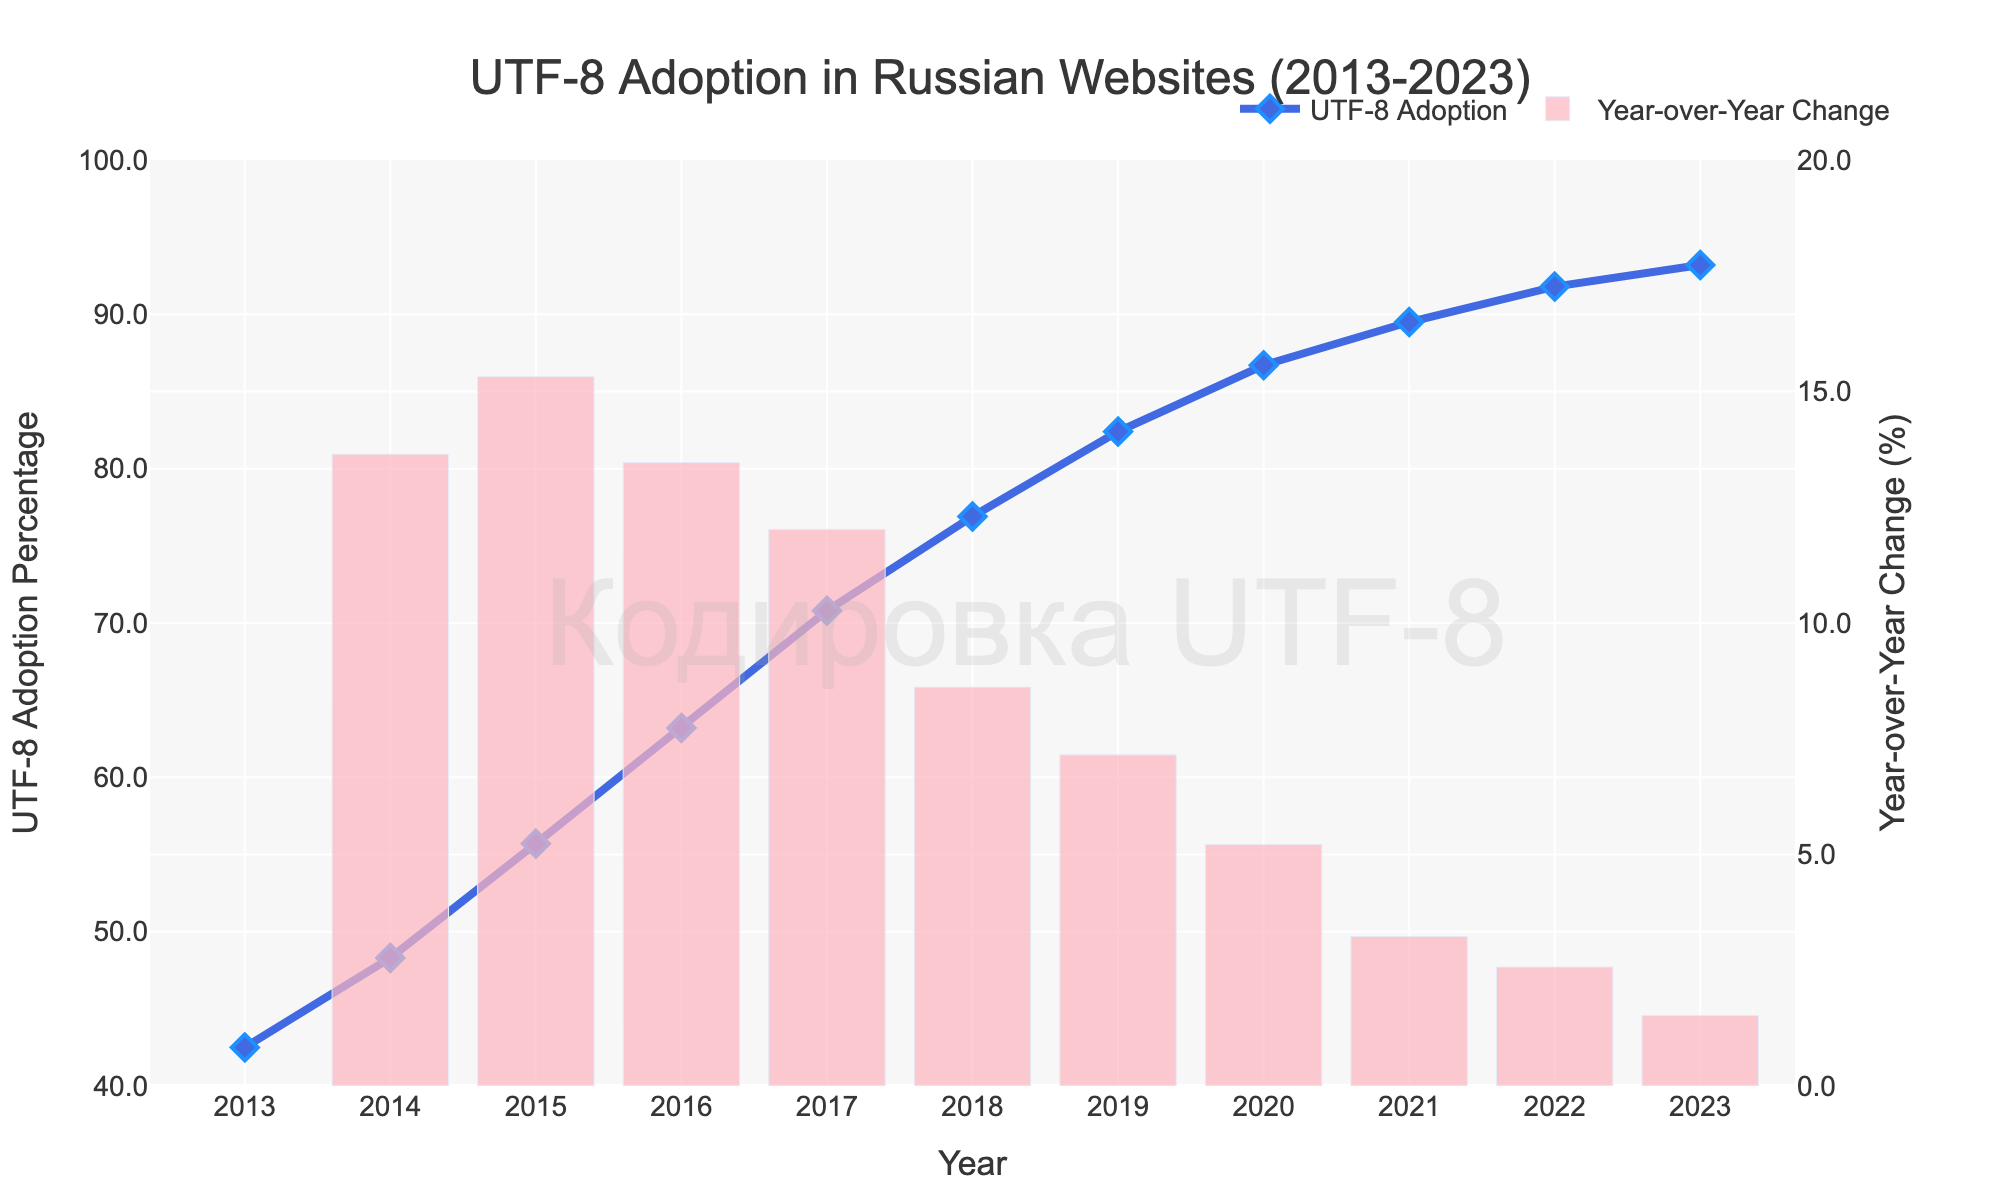What was the year with the highest increase in UTF-8 adoption? To find this, look at the bar graph showing year-over-year changes. The tallest bar represents the highest increase. In the figure, the largest year-over-year change appears to be between 2016 and 2017.
Answer: 2017 What is the overall trend of UTF-8 adoption from 2013 to 2023? Observe the line chart for the UTF-8 adoption percentage. The line shows a steady upward trend from 42.5% in 2013 to 93.2% in 2023, indicating an increasing adoption rate over the years.
Answer: Increasing Between which consecutive years was the year-over-year change the smallest? Refer to the bar graph. Identify the smallest bar, which represents the smallest year-over-year change. The shortest bar is located between 2022 and 2023.
Answer: 2022 to 2023 Compare the UTF-8 adoption rates in 2013 and 2023. How much did it increase? Look at the percentages for 2013 and 2023 and calculate the increase: 93.2% (2023) - 42.5% (2013) = 50.7%.
Answer: 50.7% What is the percentage change in UTF-8 adoption from 2019 to 2020? Locate the bar between 2019 and 2020 in the bar graph. Note the value, which appears to be around 4.3%.
Answer: 4.3% In which year did UTF-8 adoption first exceed 80%? Follow the line chart and look for the first year where the UTF-8 adoption percentage crosses 80%. This happens in 2019 with 82.4%.
Answer: 2019 Which year had an adoption percentage closest to 70%? Check the line chart for the point closest to 70%. This occurs in 2017, where the adoption rate is 70.8%.
Answer: 2017 By how many percentage points did UTF-8 adoption increase from 2015 to 2016? Find the adoption rates in 2015 (55.7%) and 2016 (63.2%). Compute the difference: 63.2% - 55.7% = 7.5%.
Answer: 7.5% What visual element marks the data points on the line chart? Identify the shapes or markers on the line chart. Each data point is marked with a blue diamond shape.
Answer: Blue diamond Did the year-over-year change in percentage ever exceed 10%? Look at the bar graph. The tallest bar represents a change exceeding 10%, which is between 2015 and 2016 as well as between 2016 and 2017.
Answer: Yes 